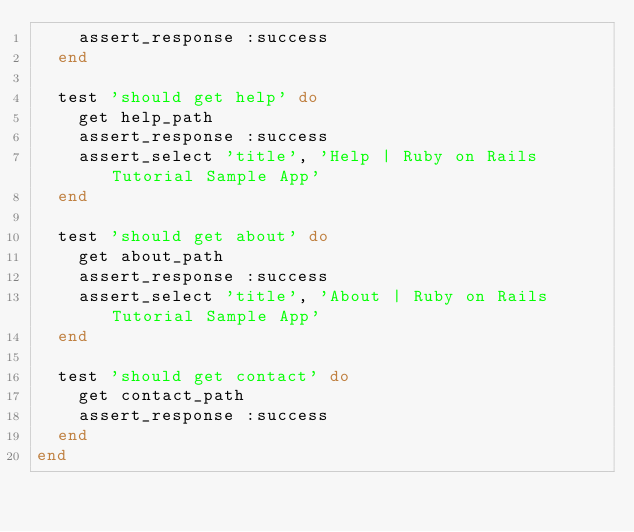Convert code to text. <code><loc_0><loc_0><loc_500><loc_500><_Ruby_>    assert_response :success
  end

  test 'should get help' do
    get help_path
    assert_response :success
    assert_select 'title', 'Help | Ruby on Rails Tutorial Sample App'
  end

  test 'should get about' do
    get about_path
    assert_response :success
    assert_select 'title', 'About | Ruby on Rails Tutorial Sample App'
  end

  test 'should get contact' do
    get contact_path
    assert_response :success
  end
end
</code> 